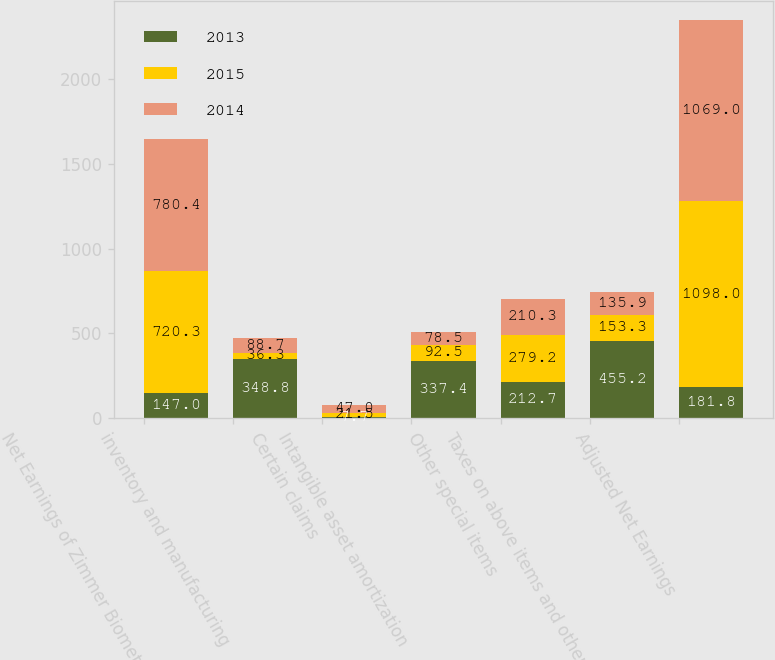Convert chart to OTSL. <chart><loc_0><loc_0><loc_500><loc_500><stacked_bar_chart><ecel><fcel>Net Earnings of Zimmer Biomet<fcel>inventory and manufacturing<fcel>Certain claims<fcel>Intangible asset amortization<fcel>Other special items<fcel>Taxes on above items and other<fcel>Adjusted Net Earnings<nl><fcel>2013<fcel>147<fcel>348.8<fcel>7.7<fcel>337.4<fcel>212.7<fcel>455.2<fcel>181.8<nl><fcel>2015<fcel>720.3<fcel>36.3<fcel>21.5<fcel>92.5<fcel>279.2<fcel>153.3<fcel>1098<nl><fcel>2014<fcel>780.4<fcel>88.7<fcel>47<fcel>78.5<fcel>210.3<fcel>135.9<fcel>1069<nl></chart> 